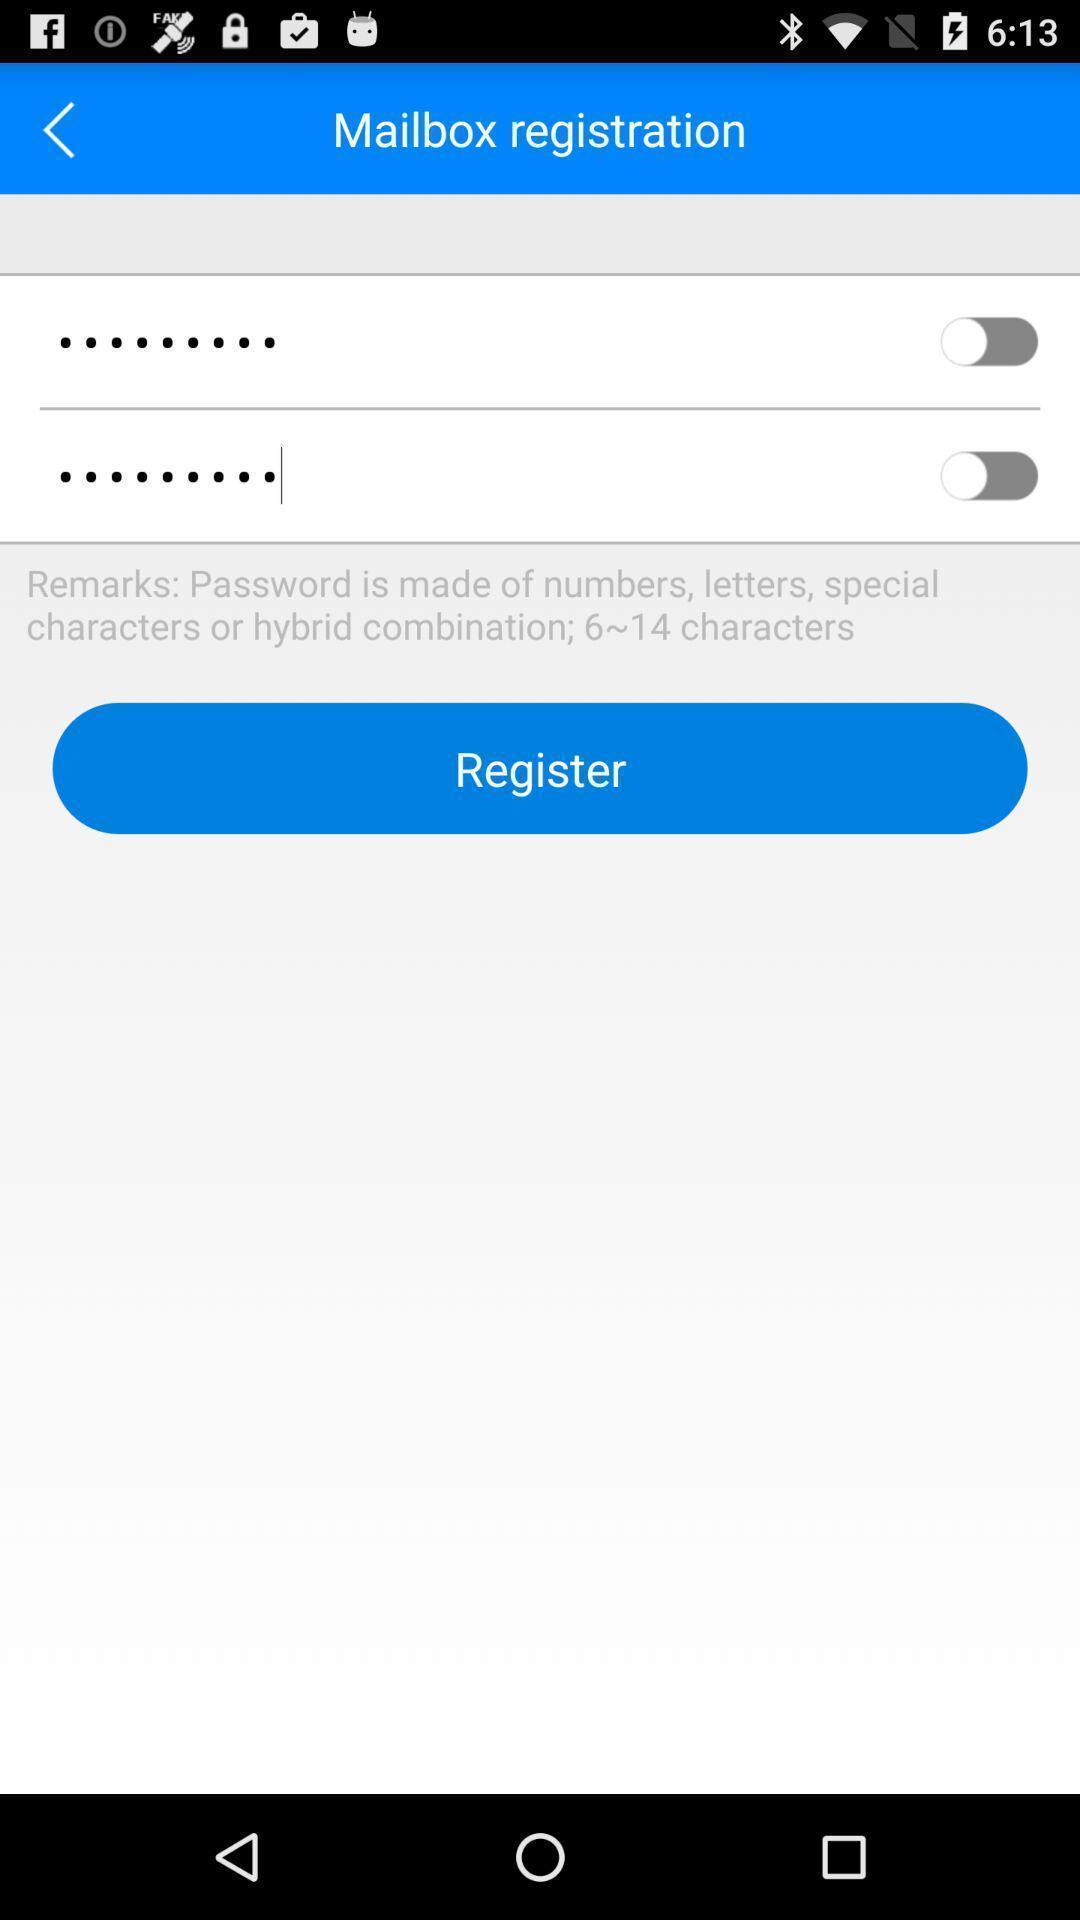Tell me what you see in this picture. Screen showing register page. 